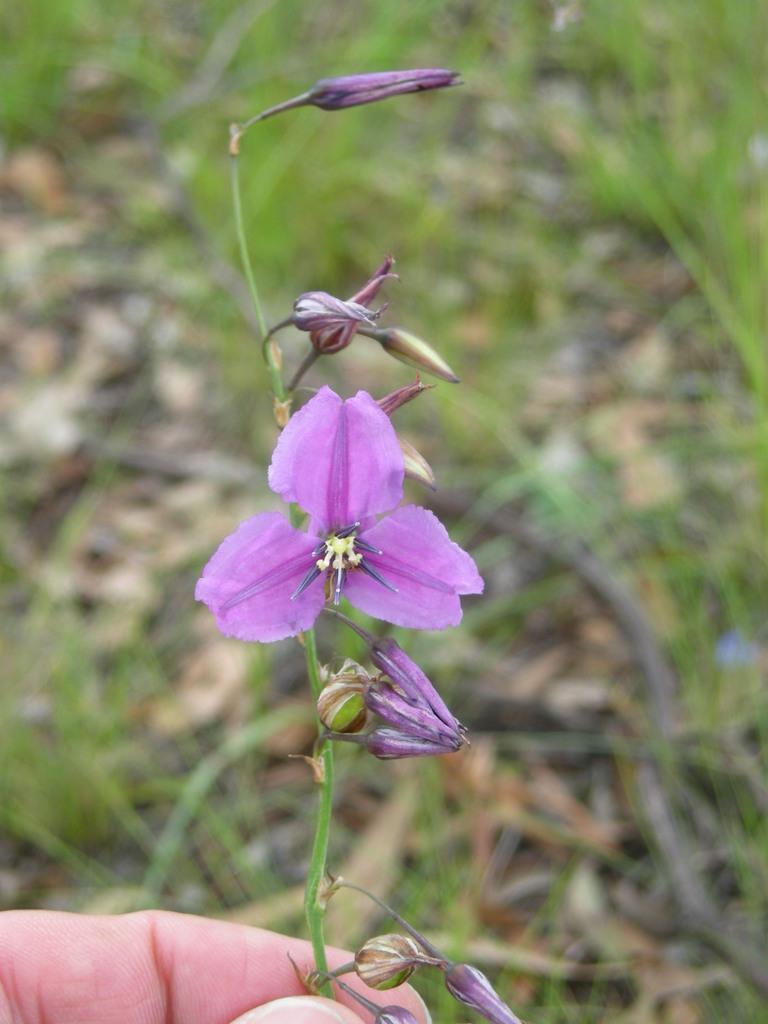How would you summarize this image in a sentence or two? On the bottom left, there is a hand of a person holding a plant which is having flowers. And the background is blurred. 